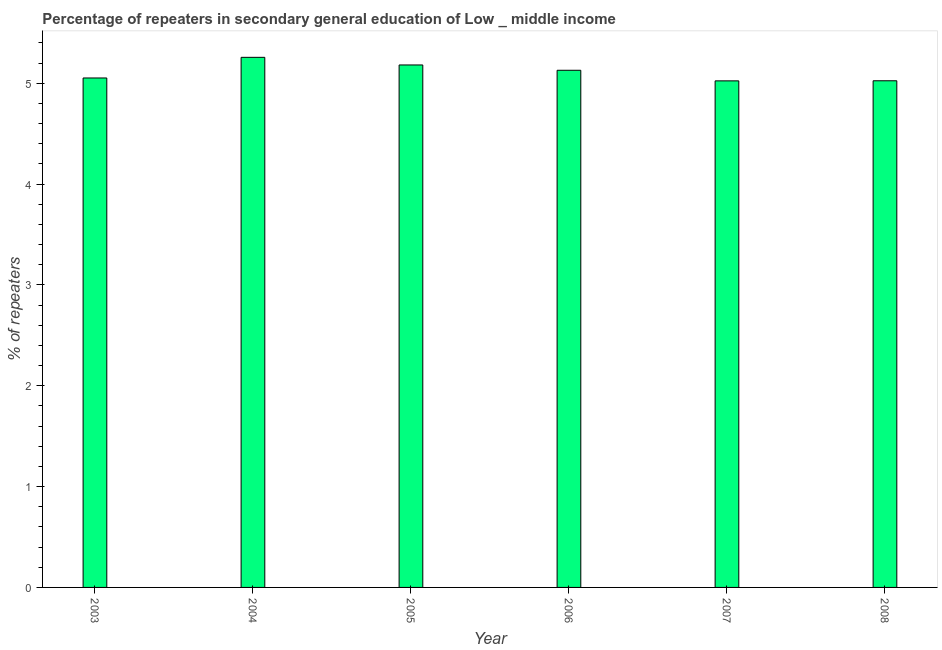Does the graph contain any zero values?
Keep it short and to the point. No. Does the graph contain grids?
Offer a terse response. No. What is the title of the graph?
Keep it short and to the point. Percentage of repeaters in secondary general education of Low _ middle income. What is the label or title of the X-axis?
Offer a terse response. Year. What is the label or title of the Y-axis?
Make the answer very short. % of repeaters. What is the percentage of repeaters in 2007?
Ensure brevity in your answer.  5.02. Across all years, what is the maximum percentage of repeaters?
Provide a short and direct response. 5.26. Across all years, what is the minimum percentage of repeaters?
Give a very brief answer. 5.02. In which year was the percentage of repeaters maximum?
Your answer should be compact. 2004. In which year was the percentage of repeaters minimum?
Give a very brief answer. 2007. What is the sum of the percentage of repeaters?
Keep it short and to the point. 30.67. What is the difference between the percentage of repeaters in 2004 and 2005?
Ensure brevity in your answer.  0.08. What is the average percentage of repeaters per year?
Your answer should be compact. 5.11. What is the median percentage of repeaters?
Ensure brevity in your answer.  5.09. Do a majority of the years between 2008 and 2004 (inclusive) have percentage of repeaters greater than 0.6 %?
Provide a short and direct response. Yes. What is the ratio of the percentage of repeaters in 2004 to that in 2008?
Ensure brevity in your answer.  1.05. Is the percentage of repeaters in 2005 less than that in 2006?
Ensure brevity in your answer.  No. What is the difference between the highest and the second highest percentage of repeaters?
Offer a terse response. 0.08. What is the difference between the highest and the lowest percentage of repeaters?
Your answer should be compact. 0.23. Are all the bars in the graph horizontal?
Make the answer very short. No. How many years are there in the graph?
Keep it short and to the point. 6. Are the values on the major ticks of Y-axis written in scientific E-notation?
Keep it short and to the point. No. What is the % of repeaters of 2003?
Provide a succinct answer. 5.05. What is the % of repeaters in 2004?
Give a very brief answer. 5.26. What is the % of repeaters of 2005?
Provide a short and direct response. 5.18. What is the % of repeaters of 2006?
Give a very brief answer. 5.13. What is the % of repeaters in 2007?
Your answer should be very brief. 5.02. What is the % of repeaters of 2008?
Make the answer very short. 5.02. What is the difference between the % of repeaters in 2003 and 2004?
Keep it short and to the point. -0.2. What is the difference between the % of repeaters in 2003 and 2005?
Your answer should be very brief. -0.13. What is the difference between the % of repeaters in 2003 and 2006?
Your answer should be very brief. -0.08. What is the difference between the % of repeaters in 2003 and 2007?
Offer a very short reply. 0.03. What is the difference between the % of repeaters in 2003 and 2008?
Offer a terse response. 0.03. What is the difference between the % of repeaters in 2004 and 2005?
Ensure brevity in your answer.  0.08. What is the difference between the % of repeaters in 2004 and 2006?
Your answer should be very brief. 0.13. What is the difference between the % of repeaters in 2004 and 2007?
Give a very brief answer. 0.23. What is the difference between the % of repeaters in 2004 and 2008?
Provide a succinct answer. 0.23. What is the difference between the % of repeaters in 2005 and 2006?
Your answer should be very brief. 0.05. What is the difference between the % of repeaters in 2005 and 2007?
Provide a short and direct response. 0.16. What is the difference between the % of repeaters in 2005 and 2008?
Provide a succinct answer. 0.16. What is the difference between the % of repeaters in 2006 and 2007?
Offer a very short reply. 0.11. What is the difference between the % of repeaters in 2006 and 2008?
Your response must be concise. 0.1. What is the difference between the % of repeaters in 2007 and 2008?
Offer a terse response. -0. What is the ratio of the % of repeaters in 2003 to that in 2004?
Keep it short and to the point. 0.96. What is the ratio of the % of repeaters in 2003 to that in 2007?
Offer a very short reply. 1.01. What is the ratio of the % of repeaters in 2003 to that in 2008?
Give a very brief answer. 1.01. What is the ratio of the % of repeaters in 2004 to that in 2005?
Provide a succinct answer. 1.01. What is the ratio of the % of repeaters in 2004 to that in 2006?
Your response must be concise. 1.02. What is the ratio of the % of repeaters in 2004 to that in 2007?
Ensure brevity in your answer.  1.05. What is the ratio of the % of repeaters in 2004 to that in 2008?
Your response must be concise. 1.05. What is the ratio of the % of repeaters in 2005 to that in 2006?
Your response must be concise. 1.01. What is the ratio of the % of repeaters in 2005 to that in 2007?
Make the answer very short. 1.03. What is the ratio of the % of repeaters in 2005 to that in 2008?
Keep it short and to the point. 1.03. What is the ratio of the % of repeaters in 2006 to that in 2007?
Offer a very short reply. 1.02. What is the ratio of the % of repeaters in 2006 to that in 2008?
Keep it short and to the point. 1.02. What is the ratio of the % of repeaters in 2007 to that in 2008?
Keep it short and to the point. 1. 